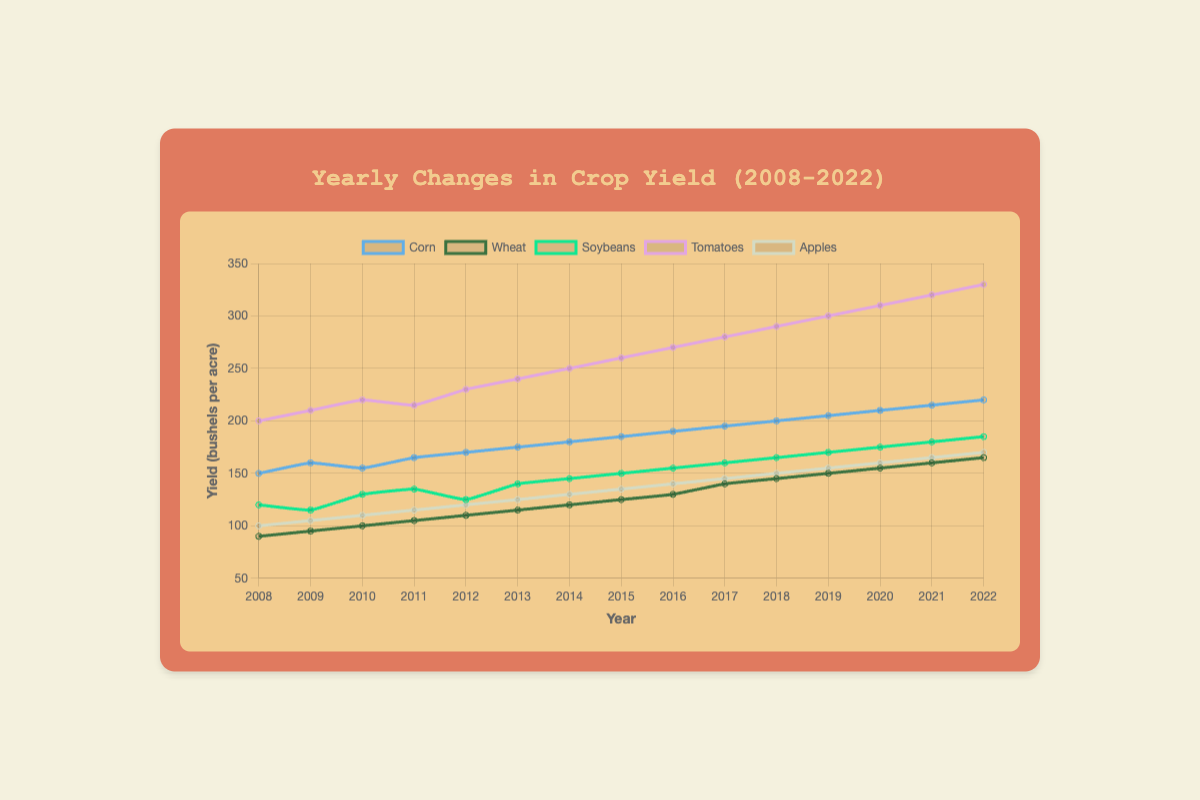How did the corn yield change from 2008 to 2022? To find the change in corn yield from 2008 to 2022, look at the values for these years. In 2008, the yield was 150 bushels per acre, and in 2022, it was 220 bushels per acre. The change is calculated by subtracting the yield in 2008 from the yield in 2022: 220 - 150 = 70 bushels per acre.
Answer: 70 bushels per acre Which year did tomatoes have the highest yield? Look at the line representing tomatoes, and identify the year where this line peaks. The highest yield for tomatoes appears in the year 2022 with a yield of 330 bushels per acre.
Answer: 2022 What is the difference in soybean yields between 2010 and 2011? Find the soybean yields for the years 2010 and 2011 from the plot. In 2010, the yield was 130 bushels per acre, and in 2011, it was 135 bushels per acre. The difference is calculated as 135 - 130 = 5 bushels per acre.
Answer: 5 bushels per acre How does the apple yield in 2008 compare to the apple yield in 2022? Compare the apple yields for 2008 and 2022 by looking at the data points for these years. In 2008, the yield was 100 bushels per acre, while in 2022, it was 170 bushels per acre. The yield in 2022 is greater by 70 bushels per acre.
Answer: 70 bushels per acre greater Which produce showed the most consistent yearly increase in yield? Examine the trend lines for each produce type. Look for the produce line that shows a steady upward trend each year without large fluctuations. Corn shows the most consistent yearly increase, as it has a steady upward trend from 150 bushels per acre in 2008 to 220 bushels per acre in 2022.
Answer: Corn In how many years did wheat yields increase compared to the previous year? Count the number of times the wheat yield in a year is greater than the wheat yield in the previous year. From the data: 2009 > 2008, 2010 > 2009, 2011 > 2010, 2012 > 2011, 2013 > 2012, 2014 > 2013, 2015 > 2014, 2016 > 2015, 2017 > 2016, 2018 > 2017, 2019 > 2018, 2020 > 2019, 2021 > 2020, 2022 > 2021. Wheat yield increased in 14 out of 14 comparisons.
Answer: 14 years What was the average apple yield between 2008 and 2022? Sum the apple yields from each year and divide by the number of years. The yields are: 100, 105, 110, 115, 120, 125, 130, 135, 140, 145, 150, 155, 160, 165, 170. The sum is 2125 and the number of years is 15. Thus, the average yield is 2125/15 = 141.67 bushels per acre.
Answer: 141.67 bushels per acre Which two produce types had the closest yields in 2016, and what was the difference in their yields? Look at the data points for each produce type in 2016. Based on the values, wheat had a yield of 130 bushels per acre, and soybeans had a yield of 155 bushels per acre. The difference is 155 - 130 = 25 bushels per acre. The closest yields in 2016 are apples (140 bushels per acre) and wheat (130 bushels per acre), with a difference of 10 bushels per acre.
Answer: Apples and wheat, 10 bushels per acre What can you infer about the trend in soybean yields over the 15-year span? Look at the line plot for soybeans from 2008 to 2022. The line shows an overall upward trend, indicating that the soybean yields have generally increased each year from 120 bushels per acre in 2008 to 185 bushels per acre in 2022.
Answer: Increasing trend 